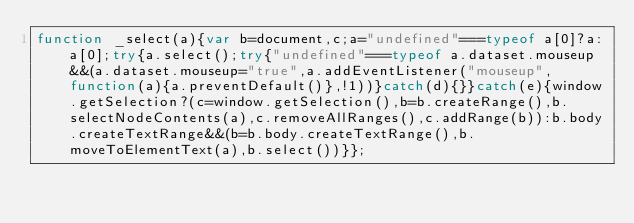<code> <loc_0><loc_0><loc_500><loc_500><_JavaScript_>function _select(a){var b=document,c;a="undefined"===typeof a[0]?a:a[0];try{a.select();try{"undefined"===typeof a.dataset.mouseup&&(a.dataset.mouseup="true",a.addEventListener("mouseup",function(a){a.preventDefault()},!1))}catch(d){}}catch(e){window.getSelection?(c=window.getSelection(),b=b.createRange(),b.selectNodeContents(a),c.removeAllRanges(),c.addRange(b)):b.body.createTextRange&&(b=b.body.createTextRange(),b.moveToElementText(a),b.select())}};</code> 